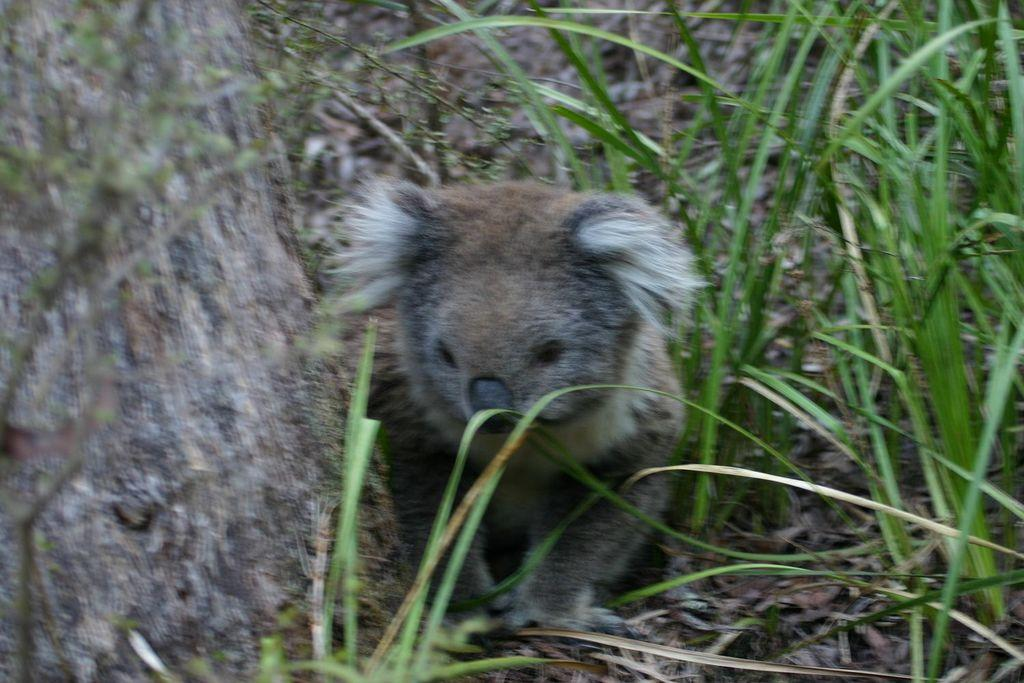What type of creature is in the image? There is a small animal in the image. Where is the animal located in relation to the grass? The animal is beside the grass. What position is the animal in? The animal is laying on the ground. Can you hear the animal talking in the image? There is no indication in the image that the animal is talking, as animals do not have the ability to talk. 